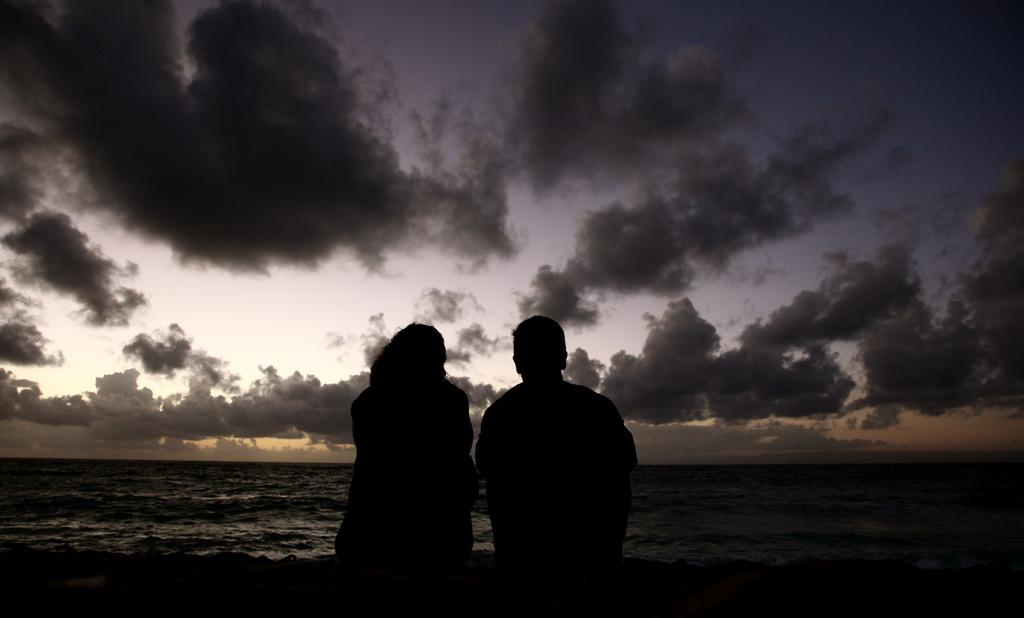How many people are sitting on the sand in the image? There are two people sitting on the sand in the image. What is in front of the people? There is a river in front of the people. What can be seen in the background of the image? The sky is visible in the background. What is present in the sky? Clouds are present in the sky. Can you see any eggs in the image? There are no eggs present in the image. Is there a jail visible in the image? There is no jail present in the image. 